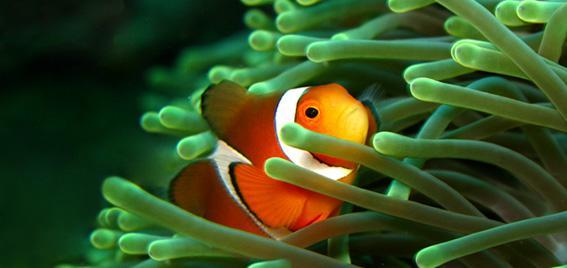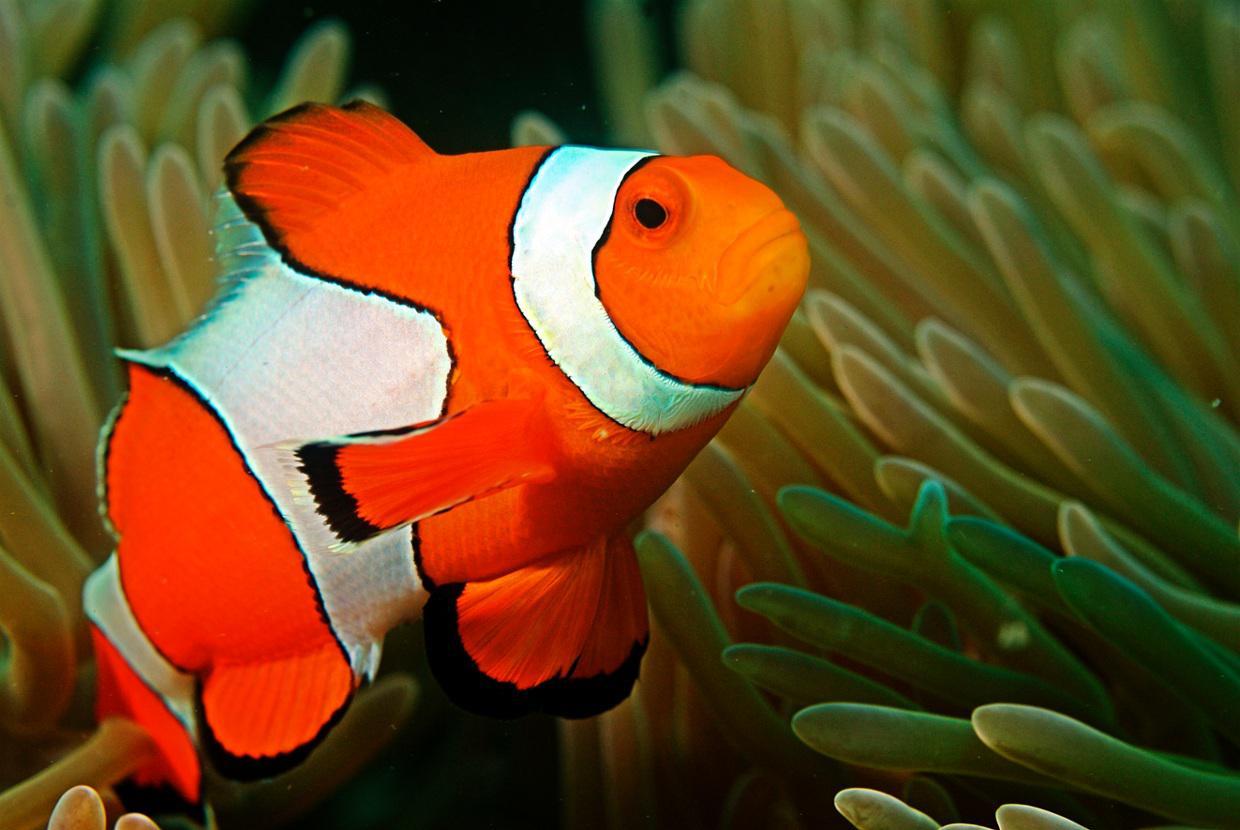The first image is the image on the left, the second image is the image on the right. Considering the images on both sides, is "A total of two clown fish are shown, facing opposite directions." valid? Answer yes or no. No. 